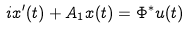<formula> <loc_0><loc_0><loc_500><loc_500>i x ^ { \prime } ( t ) + A _ { 1 } x ( t ) = \Phi ^ { * } u ( t )</formula> 